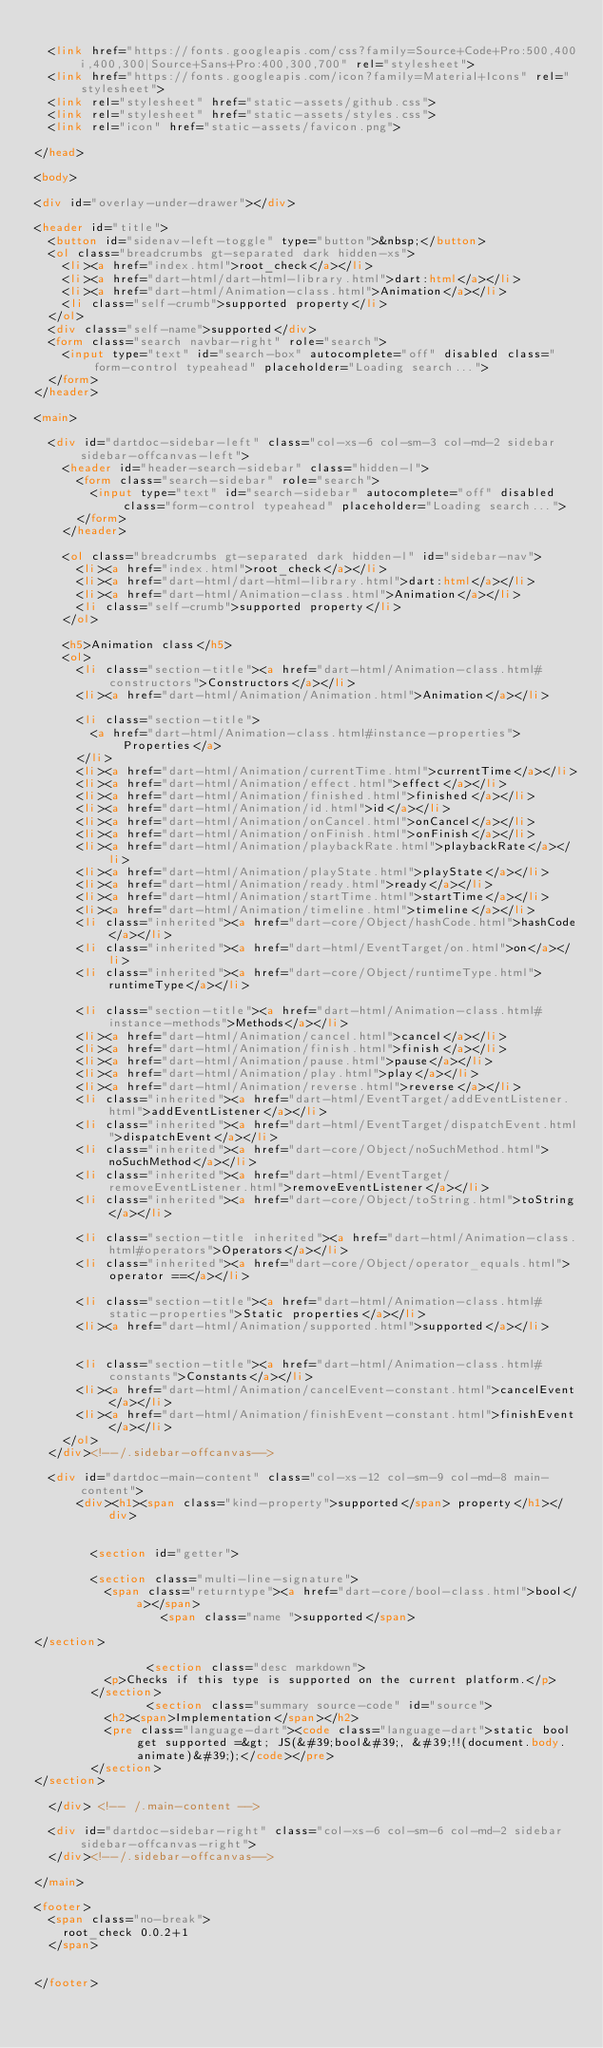Convert code to text. <code><loc_0><loc_0><loc_500><loc_500><_HTML_>
  <link href="https://fonts.googleapis.com/css?family=Source+Code+Pro:500,400i,400,300|Source+Sans+Pro:400,300,700" rel="stylesheet">
  <link href="https://fonts.googleapis.com/icon?family=Material+Icons" rel="stylesheet">
  <link rel="stylesheet" href="static-assets/github.css">
  <link rel="stylesheet" href="static-assets/styles.css">
  <link rel="icon" href="static-assets/favicon.png">
  
</head>

<body>

<div id="overlay-under-drawer"></div>

<header id="title">
  <button id="sidenav-left-toggle" type="button">&nbsp;</button>
  <ol class="breadcrumbs gt-separated dark hidden-xs">
    <li><a href="index.html">root_check</a></li>
    <li><a href="dart-html/dart-html-library.html">dart:html</a></li>
    <li><a href="dart-html/Animation-class.html">Animation</a></li>
    <li class="self-crumb">supported property</li>
  </ol>
  <div class="self-name">supported</div>
  <form class="search navbar-right" role="search">
    <input type="text" id="search-box" autocomplete="off" disabled class="form-control typeahead" placeholder="Loading search...">
  </form>
</header>

<main>

  <div id="dartdoc-sidebar-left" class="col-xs-6 col-sm-3 col-md-2 sidebar sidebar-offcanvas-left">
    <header id="header-search-sidebar" class="hidden-l">
      <form class="search-sidebar" role="search">
        <input type="text" id="search-sidebar" autocomplete="off" disabled class="form-control typeahead" placeholder="Loading search...">
      </form>
    </header>
    
    <ol class="breadcrumbs gt-separated dark hidden-l" id="sidebar-nav">
      <li><a href="index.html">root_check</a></li>
      <li><a href="dart-html/dart-html-library.html">dart:html</a></li>
      <li><a href="dart-html/Animation-class.html">Animation</a></li>
      <li class="self-crumb">supported property</li>
    </ol>
    
    <h5>Animation class</h5>
    <ol>
      <li class="section-title"><a href="dart-html/Animation-class.html#constructors">Constructors</a></li>
      <li><a href="dart-html/Animation/Animation.html">Animation</a></li>
    
      <li class="section-title">
        <a href="dart-html/Animation-class.html#instance-properties">Properties</a>
      </li>
      <li><a href="dart-html/Animation/currentTime.html">currentTime</a></li>
      <li><a href="dart-html/Animation/effect.html">effect</a></li>
      <li><a href="dart-html/Animation/finished.html">finished</a></li>
      <li><a href="dart-html/Animation/id.html">id</a></li>
      <li><a href="dart-html/Animation/onCancel.html">onCancel</a></li>
      <li><a href="dart-html/Animation/onFinish.html">onFinish</a></li>
      <li><a href="dart-html/Animation/playbackRate.html">playbackRate</a></li>
      <li><a href="dart-html/Animation/playState.html">playState</a></li>
      <li><a href="dart-html/Animation/ready.html">ready</a></li>
      <li><a href="dart-html/Animation/startTime.html">startTime</a></li>
      <li><a href="dart-html/Animation/timeline.html">timeline</a></li>
      <li class="inherited"><a href="dart-core/Object/hashCode.html">hashCode</a></li>
      <li class="inherited"><a href="dart-html/EventTarget/on.html">on</a></li>
      <li class="inherited"><a href="dart-core/Object/runtimeType.html">runtimeType</a></li>
    
      <li class="section-title"><a href="dart-html/Animation-class.html#instance-methods">Methods</a></li>
      <li><a href="dart-html/Animation/cancel.html">cancel</a></li>
      <li><a href="dart-html/Animation/finish.html">finish</a></li>
      <li><a href="dart-html/Animation/pause.html">pause</a></li>
      <li><a href="dart-html/Animation/play.html">play</a></li>
      <li><a href="dart-html/Animation/reverse.html">reverse</a></li>
      <li class="inherited"><a href="dart-html/EventTarget/addEventListener.html">addEventListener</a></li>
      <li class="inherited"><a href="dart-html/EventTarget/dispatchEvent.html">dispatchEvent</a></li>
      <li class="inherited"><a href="dart-core/Object/noSuchMethod.html">noSuchMethod</a></li>
      <li class="inherited"><a href="dart-html/EventTarget/removeEventListener.html">removeEventListener</a></li>
      <li class="inherited"><a href="dart-core/Object/toString.html">toString</a></li>
    
      <li class="section-title inherited"><a href="dart-html/Animation-class.html#operators">Operators</a></li>
      <li class="inherited"><a href="dart-core/Object/operator_equals.html">operator ==</a></li>
    
      <li class="section-title"><a href="dart-html/Animation-class.html#static-properties">Static properties</a></li>
      <li><a href="dart-html/Animation/supported.html">supported</a></li>
    
    
      <li class="section-title"><a href="dart-html/Animation-class.html#constants">Constants</a></li>
      <li><a href="dart-html/Animation/cancelEvent-constant.html">cancelEvent</a></li>
      <li><a href="dart-html/Animation/finishEvent-constant.html">finishEvent</a></li>
    </ol>
  </div><!--/.sidebar-offcanvas-->

  <div id="dartdoc-main-content" class="col-xs-12 col-sm-9 col-md-8 main-content">
      <div><h1><span class="kind-property">supported</span> property</h1></div>


        <section id="getter">
        
        <section class="multi-line-signature">
          <span class="returntype"><a href="dart-core/bool-class.html">bool</a></span>
                  <span class="name ">supported</span>
          
</section>
        
                <section class="desc markdown">
          <p>Checks if this type is supported on the current platform.</p>
        </section>
                <section class="summary source-code" id="source">
          <h2><span>Implementation</span></h2>
          <pre class="language-dart"><code class="language-dart">static bool get supported =&gt; JS(&#39;bool&#39;, &#39;!!(document.body.animate)&#39;);</code></pre>
        </section>
</section>
        
  </div> <!-- /.main-content -->

  <div id="dartdoc-sidebar-right" class="col-xs-6 col-sm-6 col-md-2 sidebar sidebar-offcanvas-right">
  </div><!--/.sidebar-offcanvas-->

</main>

<footer>
  <span class="no-break">
    root_check 0.0.2+1
  </span>

  
</footer>
</code> 